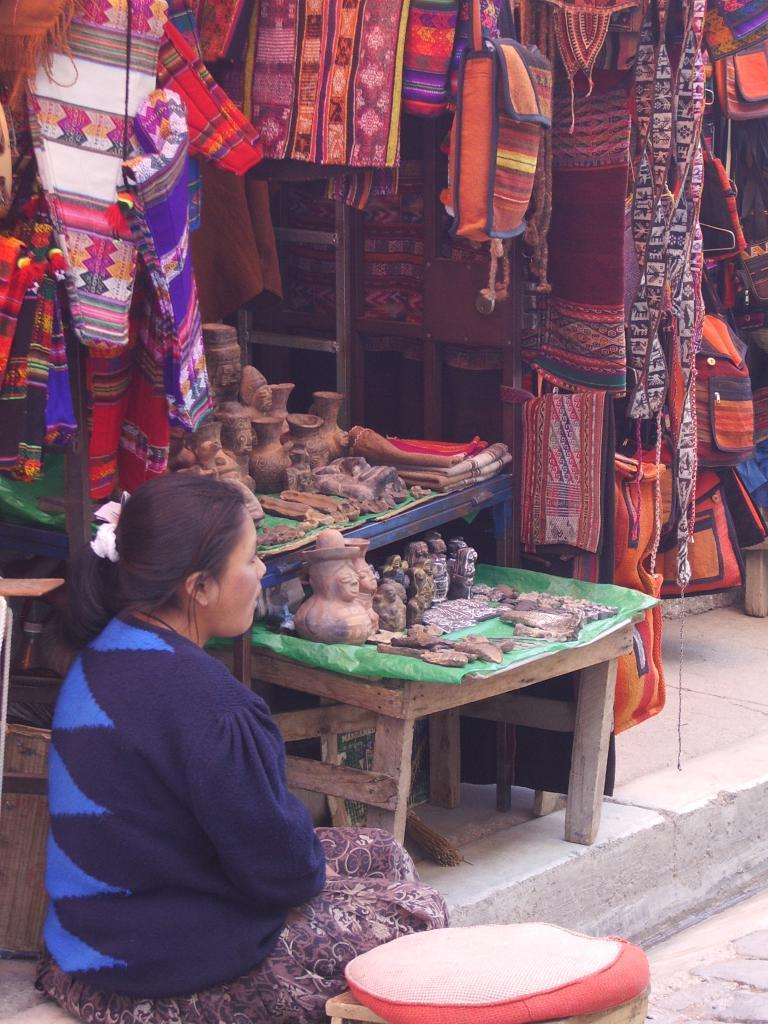Could you give a brief overview of what you see in this image? In this image there is a woman sitting on the floor. In front of her there is a table. There are sculptures on the tables. Behind the tables there are bags and clothes hanging. At the top there is a cushion on the stool. 